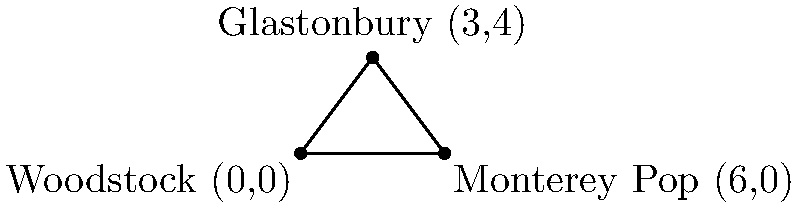Three iconic music documentaries were filmed at different locations, represented by the following coordinates:
Woodstock (0,0), Monterey Pop (6,0), and Glastonbury (3,4). Calculate the area of the triangle formed by these three points. To find the area of a triangle given three coordinates, we can use the formula:

$$\text{Area} = \frac{1}{2}|x_1(y_2 - y_3) + x_2(y_3 - y_1) + x_3(y_1 - y_2)|$$

Where $(x_1, y_1)$, $(x_2, y_2)$, and $(x_3, y_3)$ are the coordinates of the three points.

Let's assign our points:
$(x_1, y_1) = (0, 0)$ (Woodstock)
$(x_2, y_2) = (6, 0)$ (Monterey Pop)
$(x_3, y_3) = (3, 4)$ (Glastonbury)

Now, let's substitute these into our formula:

$$\begin{align*}
\text{Area} &= \frac{1}{2}|0(0 - 4) + 6(4 - 0) + 3(0 - 0)|\\
&= \frac{1}{2}|0 + 24 + 0|\\
&= \frac{1}{2}(24)\\
&= 12
\end{align*}$$

Therefore, the area of the triangle is 12 square units.
Answer: 12 square units 